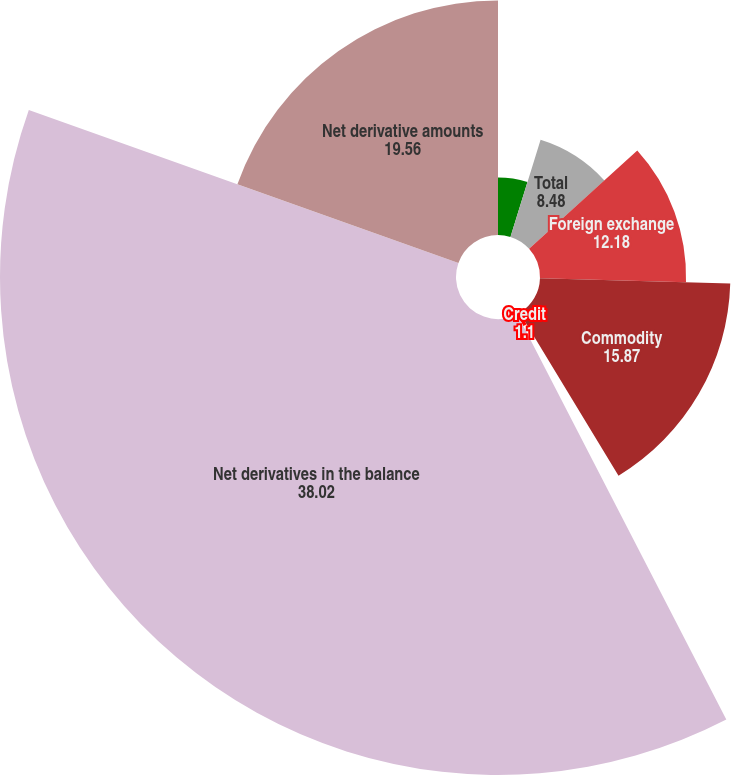Convert chart. <chart><loc_0><loc_0><loc_500><loc_500><pie_chart><fcel>Interest rate<fcel>Total<fcel>Foreign exchange<fcel>Commodity<fcel>Credit<fcel>Net derivatives in the balance<fcel>Net derivative amounts<nl><fcel>4.79%<fcel>8.48%<fcel>12.18%<fcel>15.87%<fcel>1.1%<fcel>38.02%<fcel>19.56%<nl></chart> 